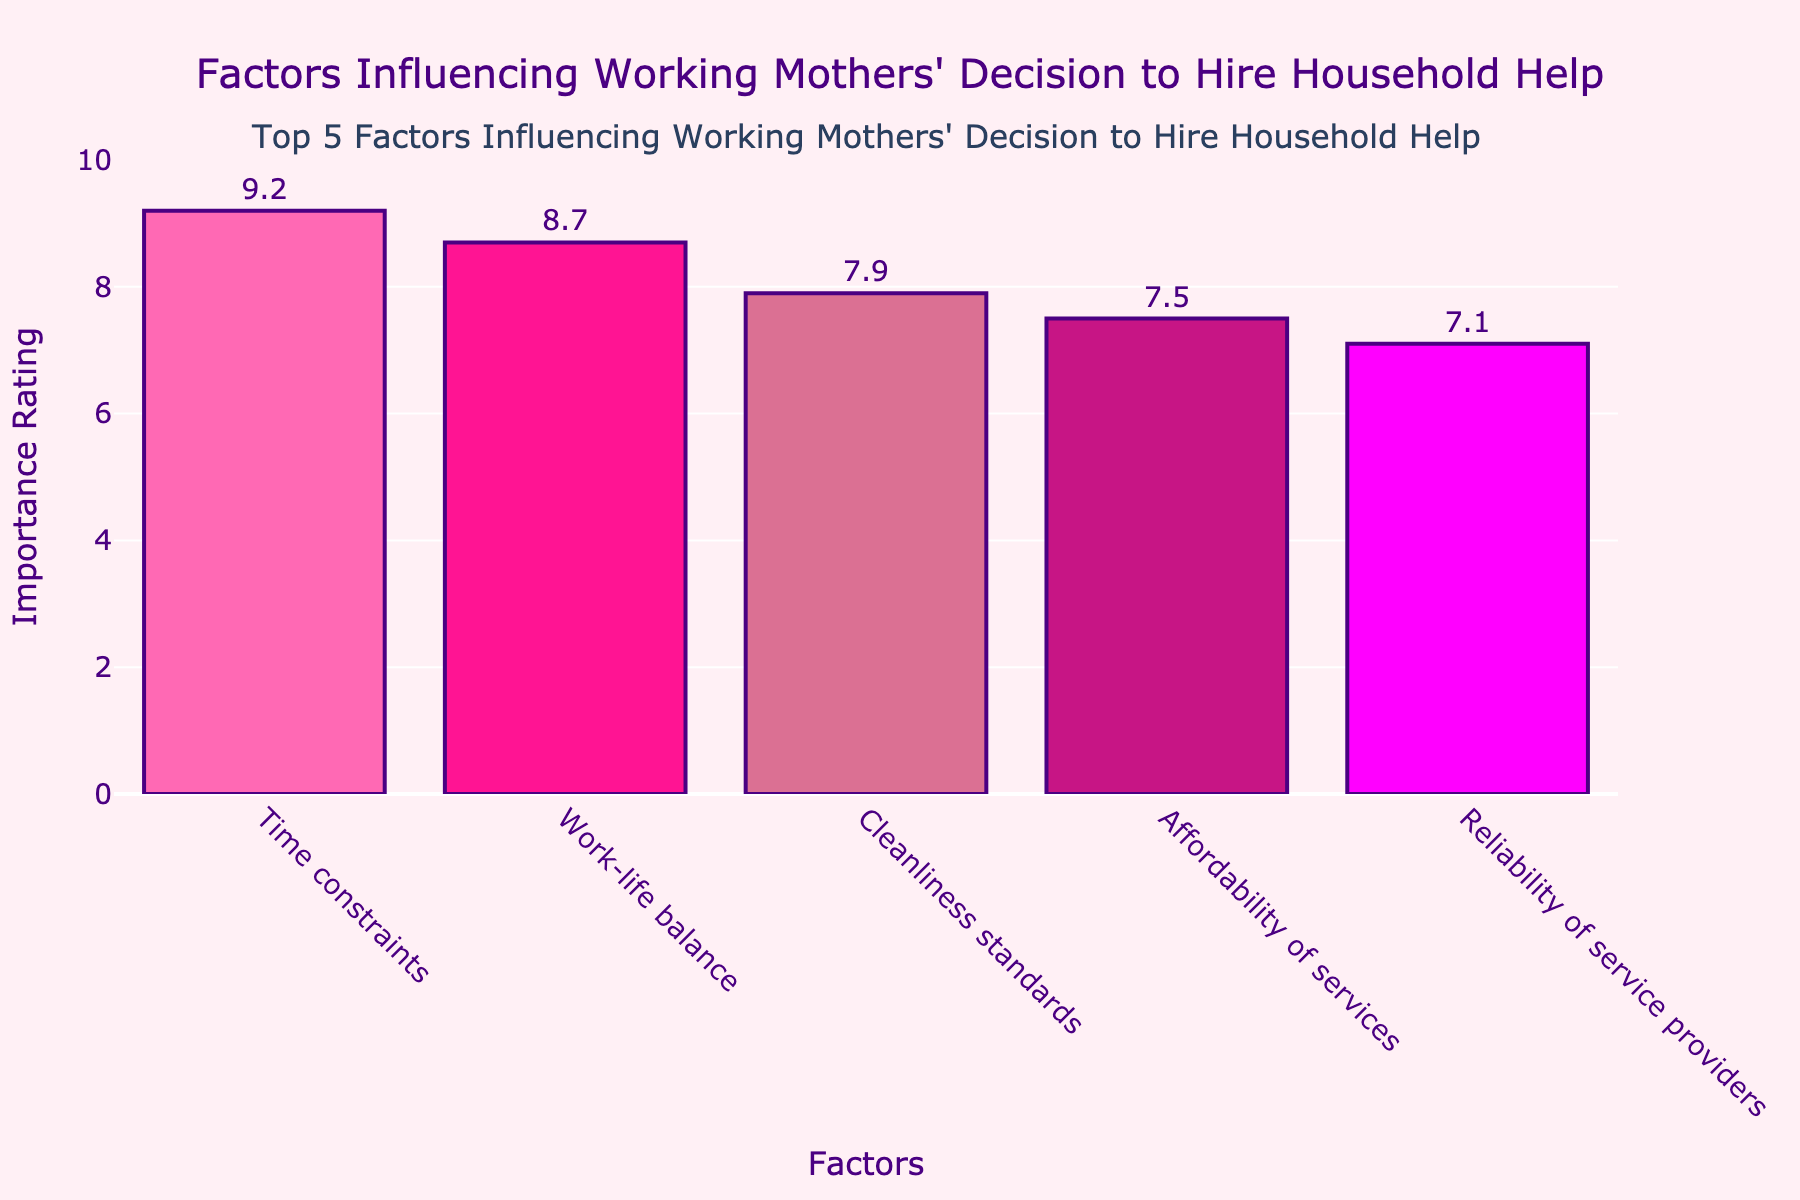What is the most important factor influencing working mothers' decision to hire household help? The highest bar in the chart corresponds to "Time constraints" with an importance rating of 9.2.
Answer: Time constraints Which factor has a higher importance rating: "Affordability of services" or "Reliability of service providers"? "Affordability of services" has a rating of 7.5, whereas "Reliability of service providers" has a rating of 7.1. Thus, "Affordability of services" is higher.
Answer: Affordability of services What is the total importance rating of "Cleanliness standards" and "Work-life balance"? Add "Cleanliness standards" (7.9) and "Work-life balance" (8.7): 7.9 + 8.7 = 16.6.
Answer: 16.6 Which factor has the lowest importance rating? The smallest bar on the chart corresponds to "Reliability of service providers" with an importance rating of 7.1.
Answer: Reliability of service providers What is the difference in importance rating between "Time constraints" and "Affordability of services"? Subtract the rating of "Affordability of services" (7.5) from "Time constraints" (9.2): 9.2 - 7.5 = 1.7.
Answer: 1.7 What is the average importance rating of all the factors? Sum all the importance ratings (9.2, 8.7, 7.9, 7.5, 7.1) and divide by the number of factors (5): (9.2 + 8.7 + 7.9 + 7.5 + 7.1) / 5 = 40.4 / 5 = 8.08.
Answer: 8.08 If you combine the importance ratings of the two least important factors, do they surpass the second highest rated factor? The two least important factors are "Affordability of services" (7.5) and "Reliability of service providers" (7.1). Their combined rating is 7.5 + 7.1 = 14.6. The second highest rated factor is "Work-life balance" with a rating of 8.7. Since 14.6 is greater than 8.7, the combined rating does surpass the second highest rated factor.
Answer: Yes What color represents the factor with the third highest importance rating? The factor with the third highest rating is "Cleanliness standards" with a rating of 7.9. The bar color for "Cleanliness standards" is displayed in a shade of pink.
Answer: Pink 